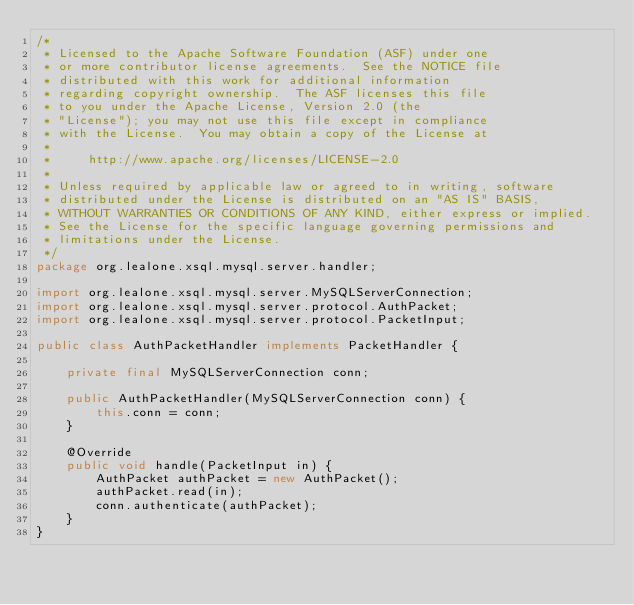Convert code to text. <code><loc_0><loc_0><loc_500><loc_500><_Java_>/*
 * Licensed to the Apache Software Foundation (ASF) under one
 * or more contributor license agreements.  See the NOTICE file
 * distributed with this work for additional information
 * regarding copyright ownership.  The ASF licenses this file
 * to you under the Apache License, Version 2.0 (the
 * "License"); you may not use this file except in compliance
 * with the License.  You may obtain a copy of the License at
 *
 *     http://www.apache.org/licenses/LICENSE-2.0
 *
 * Unless required by applicable law or agreed to in writing, software
 * distributed under the License is distributed on an "AS IS" BASIS,
 * WITHOUT WARRANTIES OR CONDITIONS OF ANY KIND, either express or implied.
 * See the License for the specific language governing permissions and
 * limitations under the License.
 */
package org.lealone.xsql.mysql.server.handler;

import org.lealone.xsql.mysql.server.MySQLServerConnection;
import org.lealone.xsql.mysql.server.protocol.AuthPacket;
import org.lealone.xsql.mysql.server.protocol.PacketInput;

public class AuthPacketHandler implements PacketHandler {

    private final MySQLServerConnection conn;

    public AuthPacketHandler(MySQLServerConnection conn) {
        this.conn = conn;
    }

    @Override
    public void handle(PacketInput in) {
        AuthPacket authPacket = new AuthPacket();
        authPacket.read(in);
        conn.authenticate(authPacket);
    }
}
</code> 